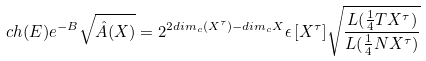<formula> <loc_0><loc_0><loc_500><loc_500>c h ( E ) e ^ { - B } \sqrt { \hat { A } ( { X } ) } = 2 ^ { 2 d i m _ { c } ( { X } ^ { \tau } ) - d i m _ { c } { X } } \epsilon \, [ { X } ^ { \tau } ] \sqrt { \frac { L ( \frac { 1 } { 4 } T { X } ^ { \tau } ) } { L ( \frac { 1 } { 4 } N { X } ^ { \tau } ) } }</formula> 